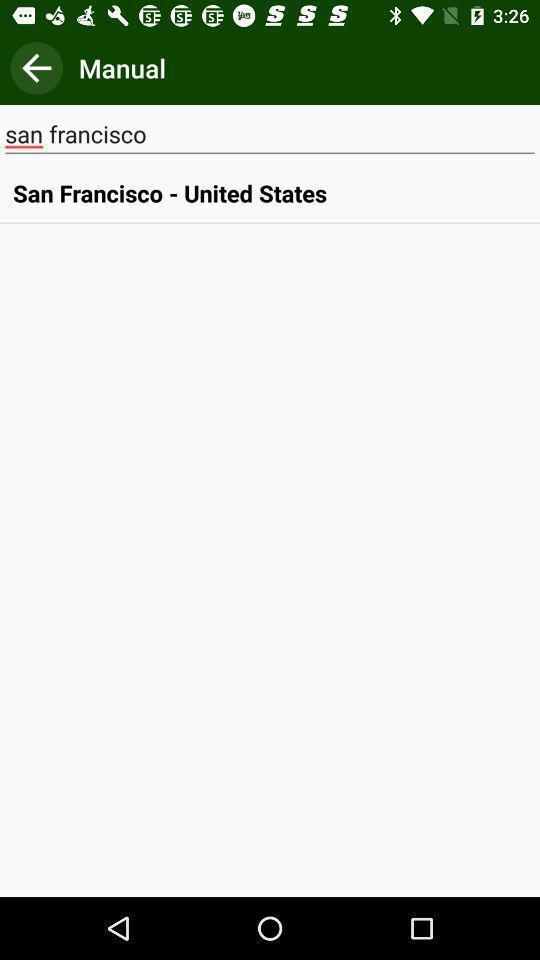Provide a textual representation of this image. Search bar to search places. 